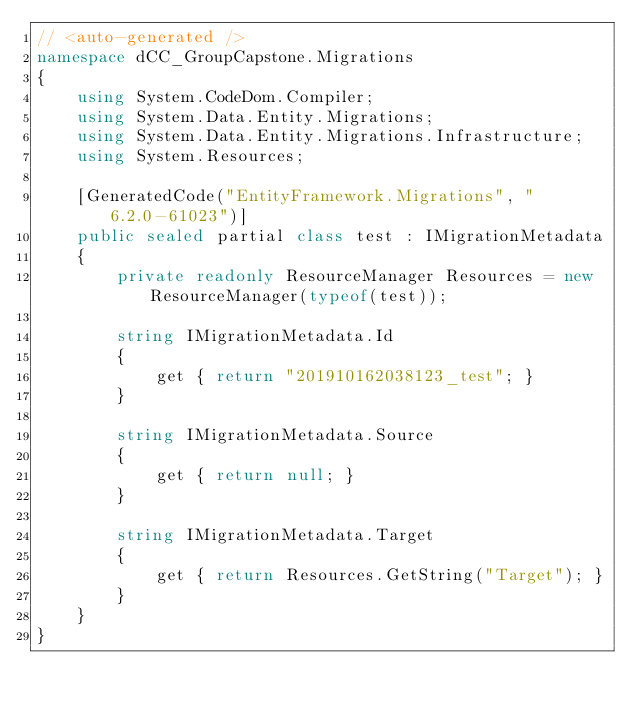Convert code to text. <code><loc_0><loc_0><loc_500><loc_500><_C#_>// <auto-generated />
namespace dCC_GroupCapstone.Migrations
{
    using System.CodeDom.Compiler;
    using System.Data.Entity.Migrations;
    using System.Data.Entity.Migrations.Infrastructure;
    using System.Resources;
    
    [GeneratedCode("EntityFramework.Migrations", "6.2.0-61023")]
    public sealed partial class test : IMigrationMetadata
    {
        private readonly ResourceManager Resources = new ResourceManager(typeof(test));
        
        string IMigrationMetadata.Id
        {
            get { return "201910162038123_test"; }
        }
        
        string IMigrationMetadata.Source
        {
            get { return null; }
        }
        
        string IMigrationMetadata.Target
        {
            get { return Resources.GetString("Target"); }
        }
    }
}
</code> 